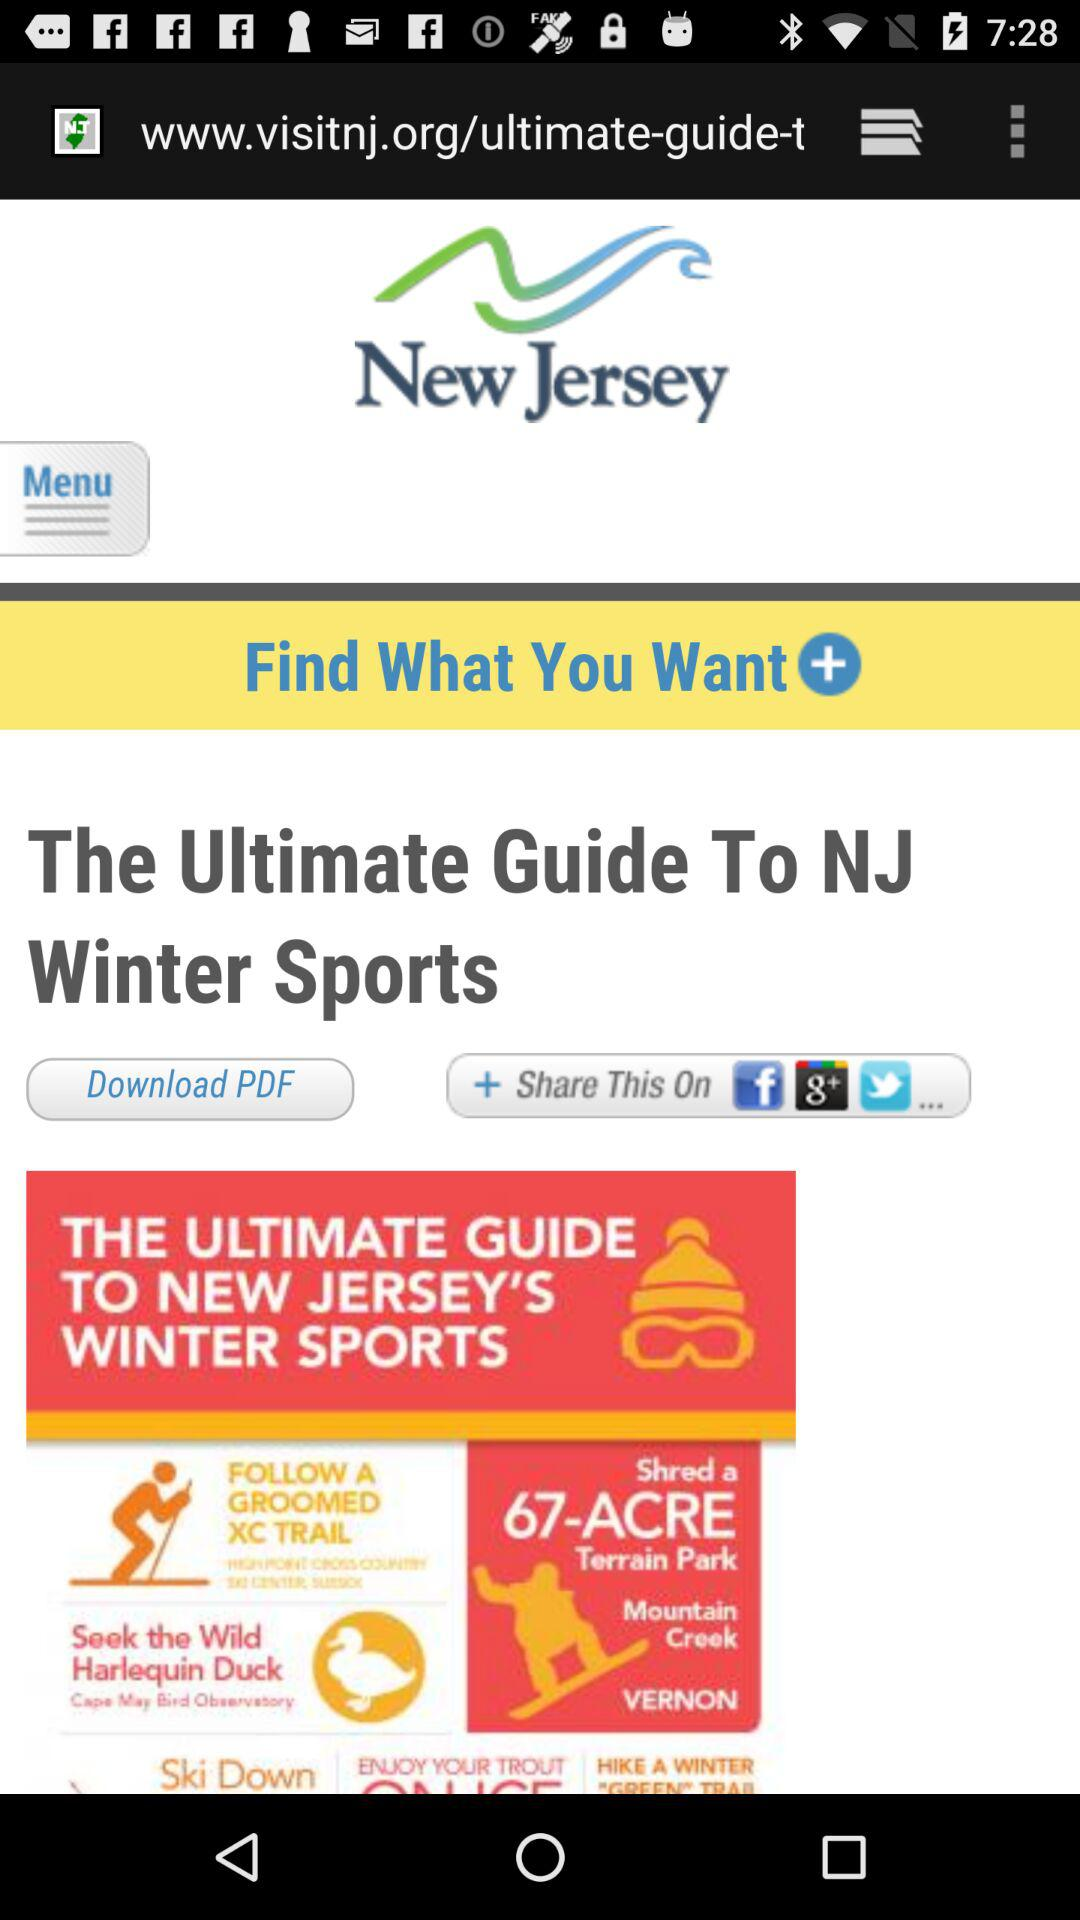What is the title? The title is "The Ultimate Guide To NJ Winter Sports". 